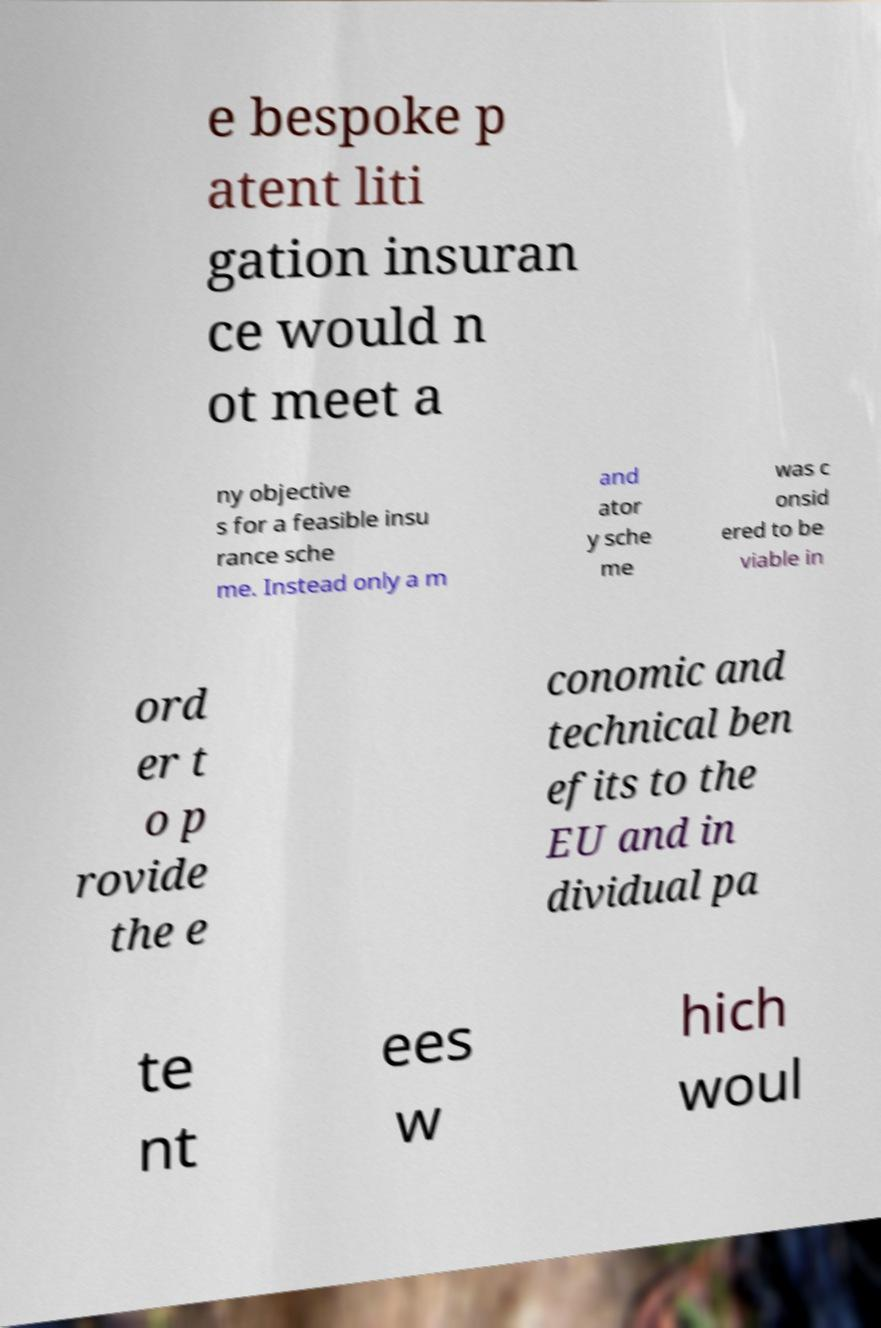Please read and relay the text visible in this image. What does it say? e bespoke p atent liti gation insuran ce would n ot meet a ny objective s for a feasible insu rance sche me. Instead only a m and ator y sche me was c onsid ered to be viable in ord er t o p rovide the e conomic and technical ben efits to the EU and in dividual pa te nt ees w hich woul 